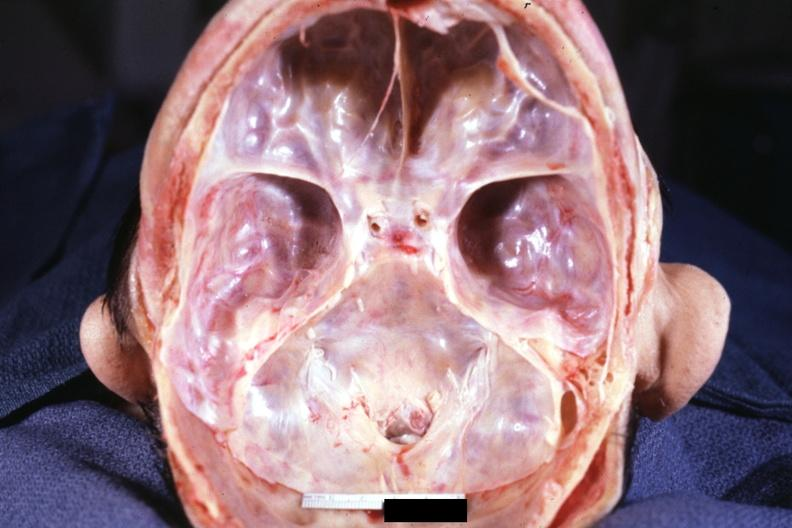what is present?
Answer the question using a single word or phrase. Bone, calvarium 